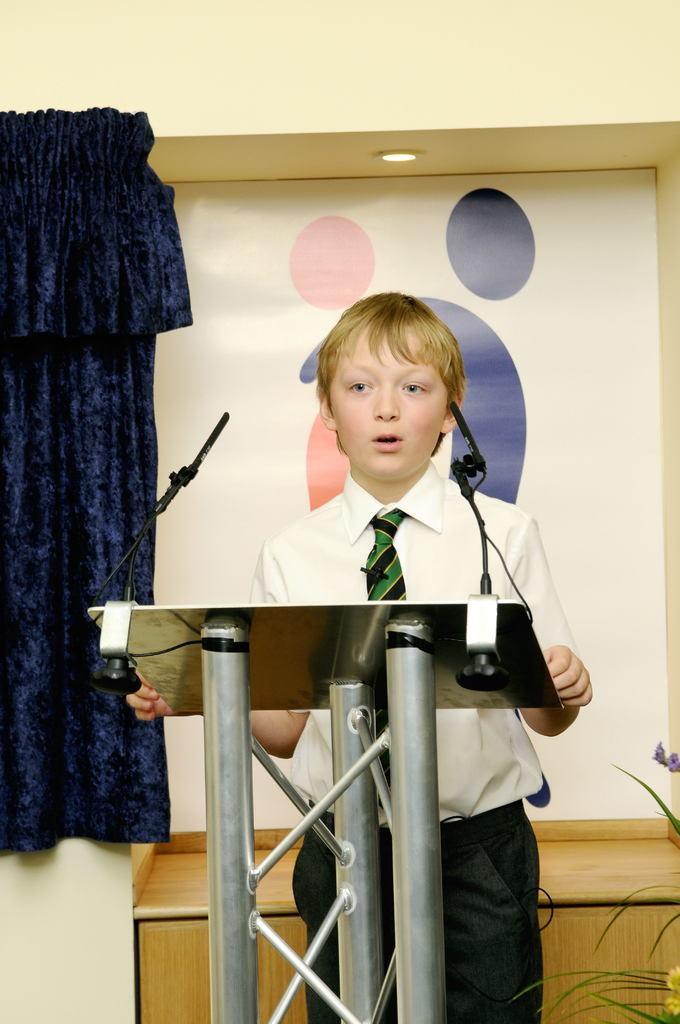How would you summarize this image in a sentence or two? In this picture there is a boy wearing student uniform standing at the speech desk and giving the speech. Behind there is a white color board and blue curtain. 